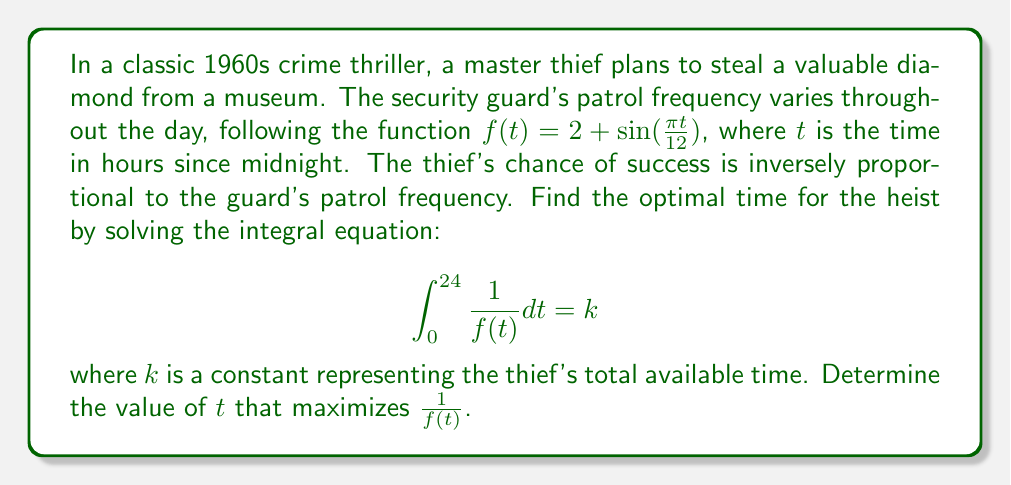Solve this math problem. To solve this problem, we'll follow these steps:

1) First, we need to find the integral of $\frac{1}{f(t)}$:

   $$\int \frac{1}{f(t)} dt = \int \frac{1}{2 + \sin(\frac{\pi t}{12})} dt$$

   This is a complex integral that doesn't have an elementary antiderivative.

2) However, we don't need to solve the integral to find the optimal time. We can maximize $\frac{1}{f(t)}$ by minimizing $f(t)$.

3) To find the minimum of $f(t) = 2 + \sin(\frac{\pi t}{12})$, we need to find where its derivative is zero:

   $$f'(t) = \frac{\pi}{12} \cos(\frac{\pi t}{12}) = 0$$

4) This occurs when $\cos(\frac{\pi t}{12}) = 0$, which happens when $\frac{\pi t}{12} = \frac{\pi}{2}$ or $\frac{3\pi}{2}$.

5) Solving for $t$:
   
   For $\frac{\pi t}{12} = \frac{\pi}{2}$: $t = 6$
   For $\frac{\pi t}{12} = \frac{3\pi}{2}$: $t = 18$

6) $f(6) = 2 + 1 = 3$ and $f(18) = 2 - 1 = 1$

Therefore, $f(t)$ reaches its minimum at $t = 18$, which corresponds to 6:00 PM.
Answer: 18 hours (6:00 PM) 